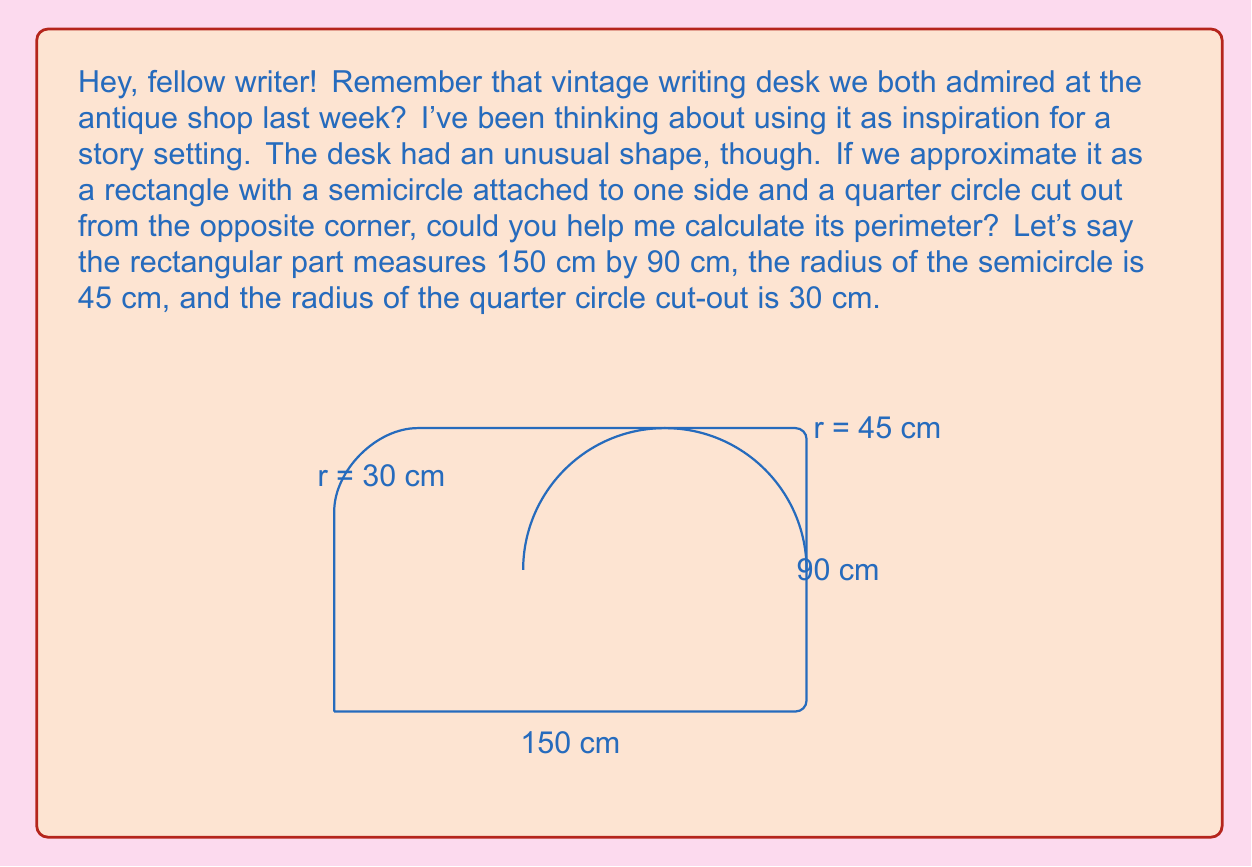Provide a solution to this math problem. Let's break this down step-by-step:

1) First, we need to calculate the perimeter of the rectangular part:
   $$P_{rectangle} = 2(150 + 90) = 2(240) = 480 \text{ cm}$$

2) Next, we need to subtract the length of the quarter circle cut-out:
   $$L_{quarter} = 30 \text{ cm}$$

3) Now, we add the length of the semicircle:
   The circumference of a full circle is $2\pi r$, so a semicircle is $\pi r$.
   $$L_{semicircle} = \pi r = \pi(45) = 45\pi \text{ cm}$$

4) Finally, we need to add the arc length of the quarter circle cut-out:
   A quarter of a circle's circumference is $\frac{1}{2}\pi r$.
   $$L_{arc} = \frac{1}{2}\pi(30) = 15\pi \text{ cm}$$

5) Now we can sum up all these parts:
   $$P_{total} = P_{rectangle} - L_{quarter} + L_{semicircle} + L_{arc}$$
   $$P_{total} = 480 - 30 + 45\pi + 15\pi$$
   $$P_{total} = 450 + 60\pi \text{ cm}$$

6) If we want to approximate this to a decimal:
   $$P_{total} \approx 450 + 60(3.14159) \approx 638.5 \text{ cm}$$
Answer: The perimeter of the writing desk is $450 + 60\pi$ cm, or approximately 638.5 cm. 